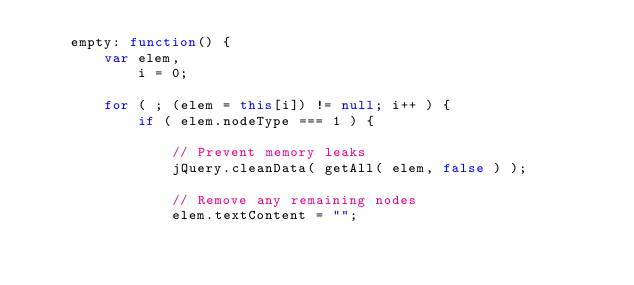<code> <loc_0><loc_0><loc_500><loc_500><_JavaScript_>	empty: function() {
		var elem,
			i = 0;

		for ( ; (elem = this[i]) != null; i++ ) {
			if ( elem.nodeType === 1 ) {

				// Prevent memory leaks
				jQuery.cleanData( getAll( elem, false ) );

				// Remove any remaining nodes
				elem.textContent = "";</code> 